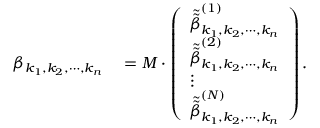<formula> <loc_0><loc_0><loc_500><loc_500>\begin{array} { r l } { \beta _ { k _ { 1 } , k _ { 2 } , \cdots , k _ { n } } } & = M \cdot \left ( \begin{array} { l } { \tilde { \tilde { \beta } } _ { k _ { 1 } , k _ { 2 } , \cdots , k _ { n } } ^ { ( 1 ) } } \\ { \tilde { \tilde { \beta } } _ { k _ { 1 } , k _ { 2 } , \cdots , k _ { n } } ^ { ( 2 ) } } \\ { \vdots } \\ { \tilde { \tilde { \beta } } _ { k _ { 1 } , k _ { 2 } , \cdots , k _ { n } } ^ { ( N ) } } \end{array} \right ) . } \end{array}</formula> 